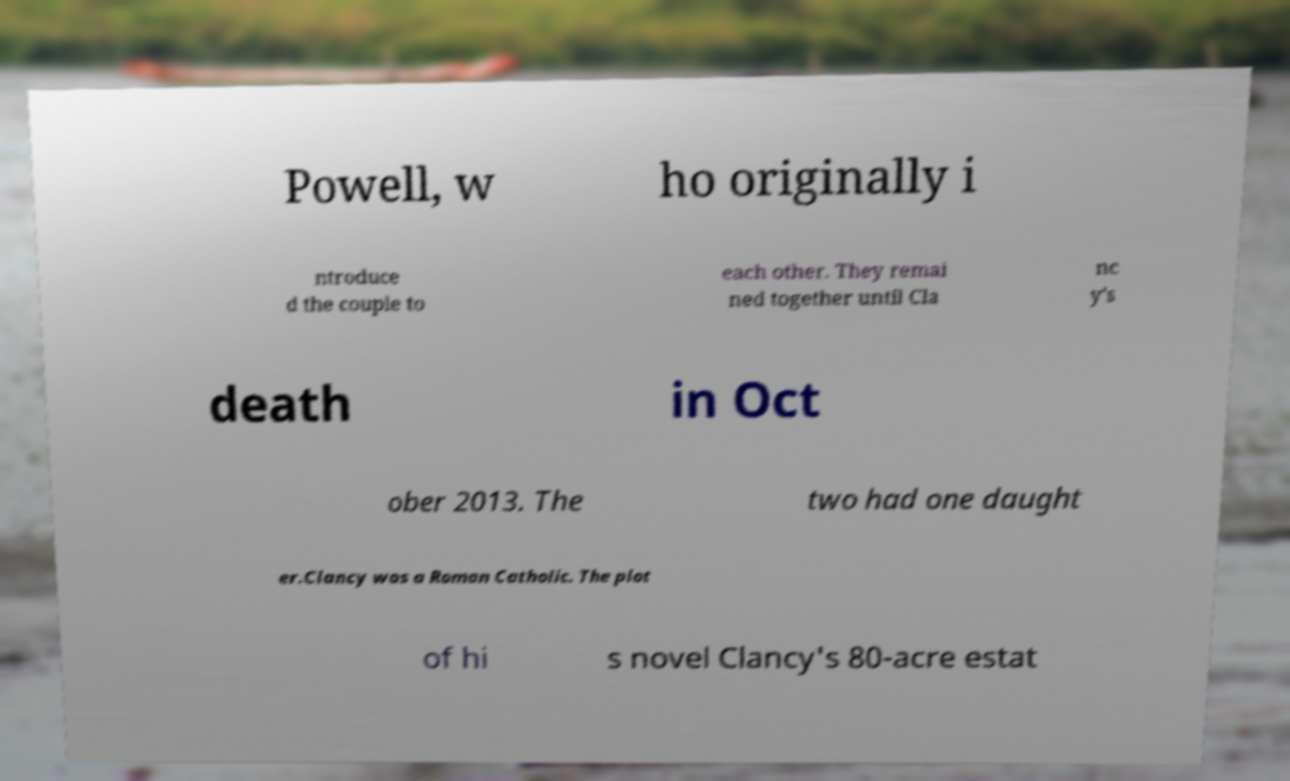Please identify and transcribe the text found in this image. Powell, w ho originally i ntroduce d the couple to each other. They remai ned together until Cla nc y's death in Oct ober 2013. The two had one daught er.Clancy was a Roman Catholic. The plot of hi s novel Clancy's 80-acre estat 